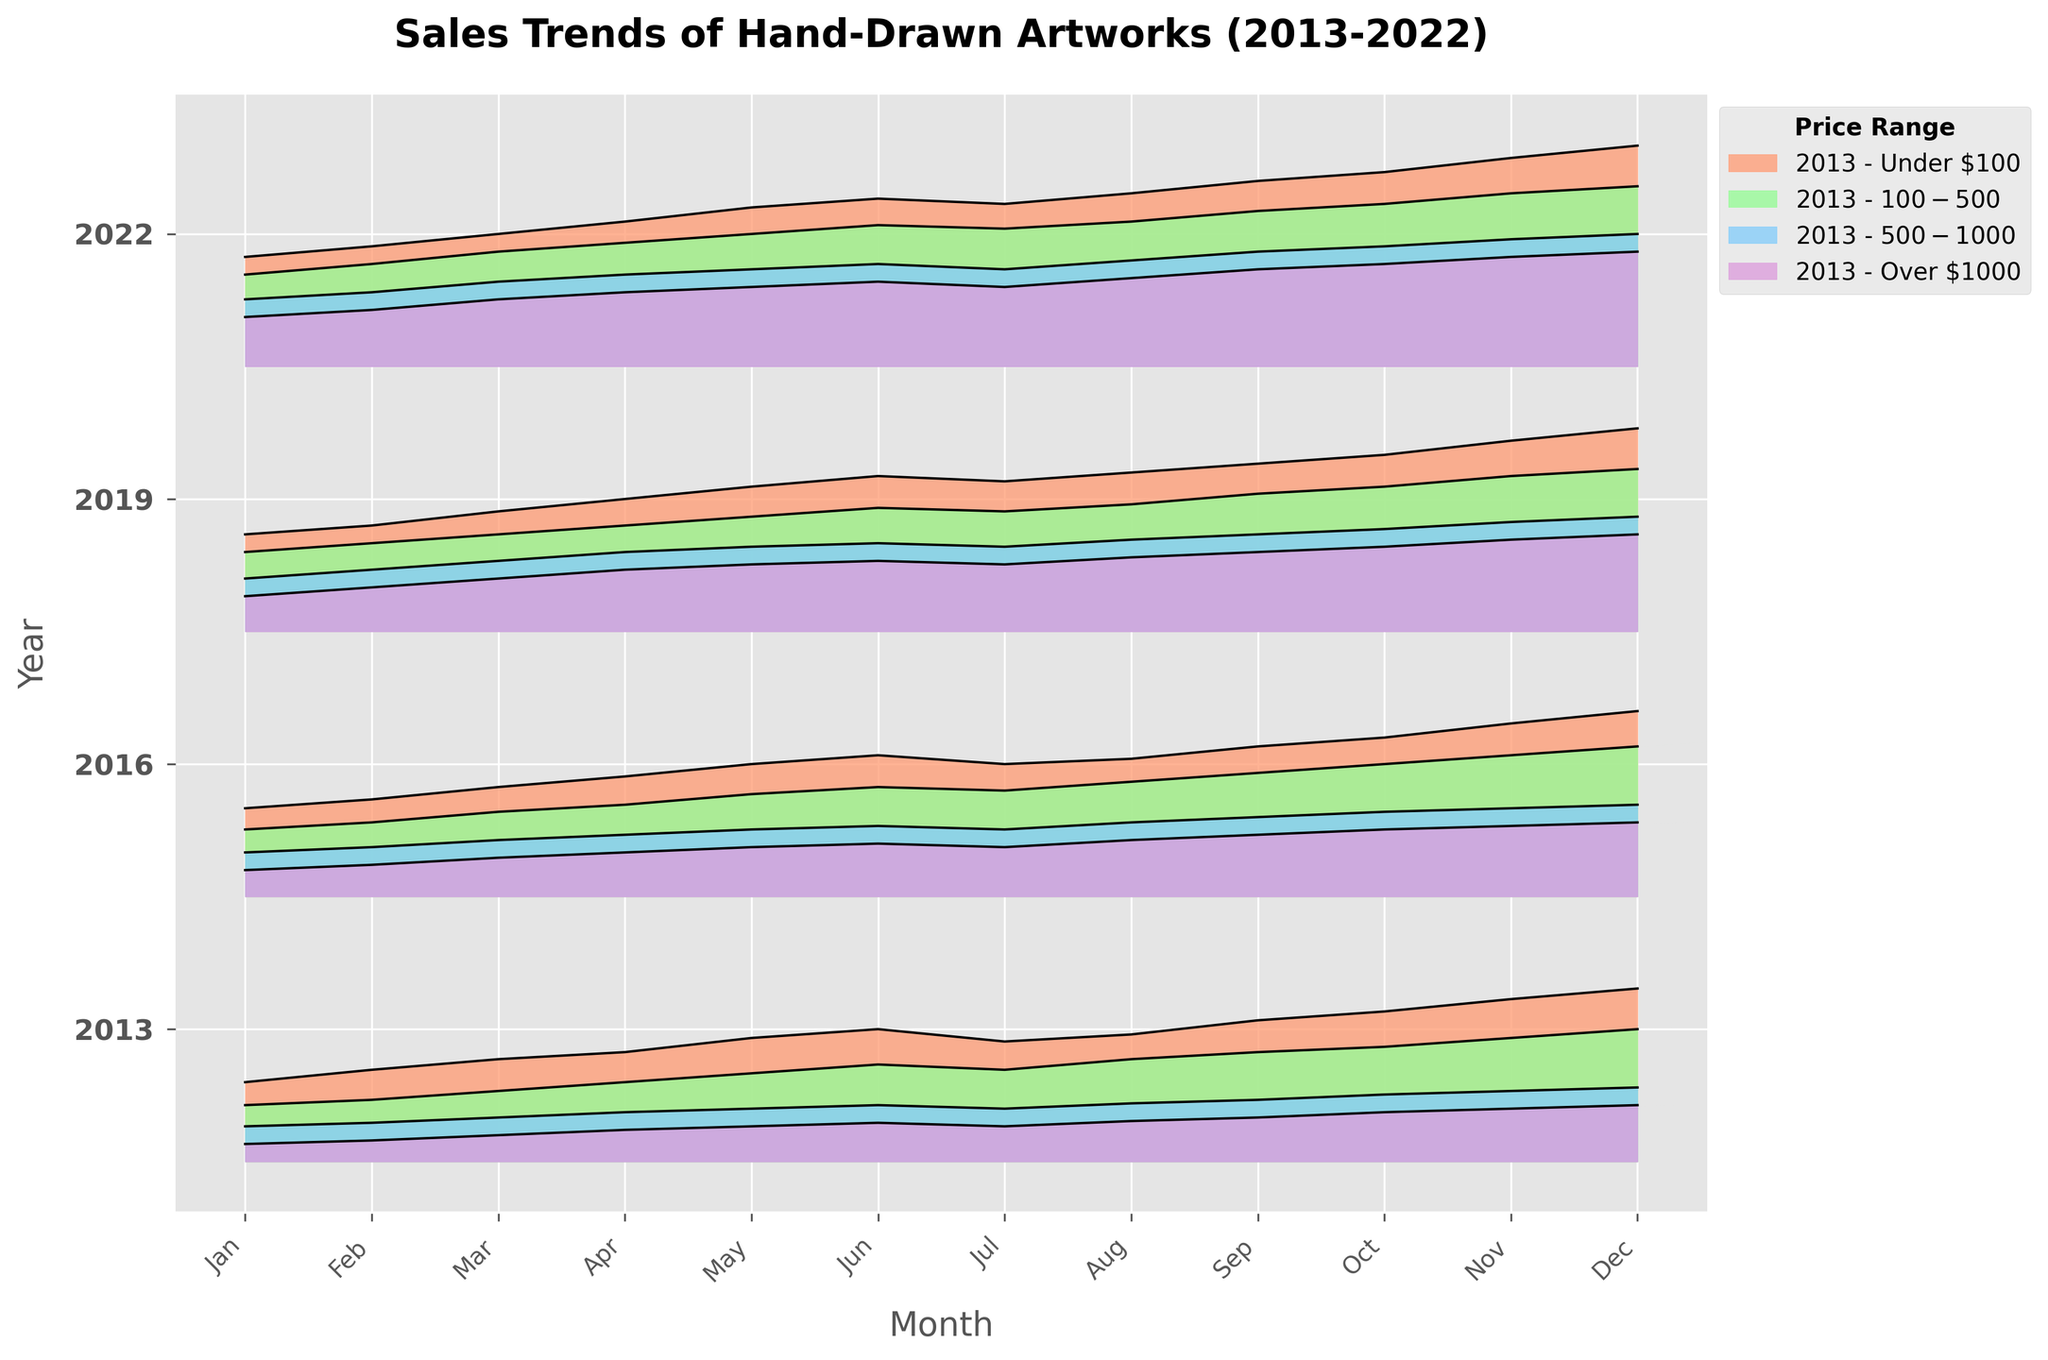What is the title of the plot? The title of the plot is located at the top and reads 'Sales Trends of Hand-Drawn Artworks (2013-2022)'.
Answer: Sales Trends of Hand-Drawn Artworks (2013-2022) Which price range appears in the legend with a light purple color? The light purple color in the legend represents the price range 'Over $1000'. By comparing the colors in the legend on the right side with the filled areas in the plot, we identify this.
Answer: Over $1000 Which year had the highest sales for 'Under $100' price range in December? Look for the peaks for 'Under $100' price range color in December across the years. 2022 has the highest peak indicating the highest sales.
Answer: 2022 On average, how does the sales trend for the 'Under $100' price range change from January to June over the years? For each year, calculate the average increase from January to June for 'Under $100' by looking at the slope. The plot shows an overall upward trend from January to June every year.
Answer: Upward Between 2013 and 2022, which price range had the least variability in sales trends throughout the months? Compare the fluctuations within each price range across years. The 'Over $1000' price range shows the least variability as its lines are more consistent and less volatile.
Answer: Over $1000 Compare the sales trends in December 2019 and December 2022 for the $500-$1000 price range. Find the sales values for $500-$1000 in December of both years. December 2022 has higher sales compared to December 2019, as indicated by a higher peak.
Answer: Higher in 2022 What month shows the highest sales increase for the year 2016 in the 'Under $100' price range? For the year 2016, look at the 'Under $100' price range line and identify the month with the steepest positive slope. The largest increase occurs around May to June.
Answer: June Which year has the most uniform sales trend across all price ranges? Evaluate the consistency of sales across price ranges for each year. 2022 shows the most uniform trends as the lines in each price range are evenly distributed without drastic changes.
Answer: 2022 How do the sales trends for the 'Under $100' price range compare between January 2013 and January 2019? Compare the values on the y-axis for January 2013 and January 2019 for 'Under $100' price range. January 2019 shows higher sales compared to January 2013.
Answer: Higher in 2019 